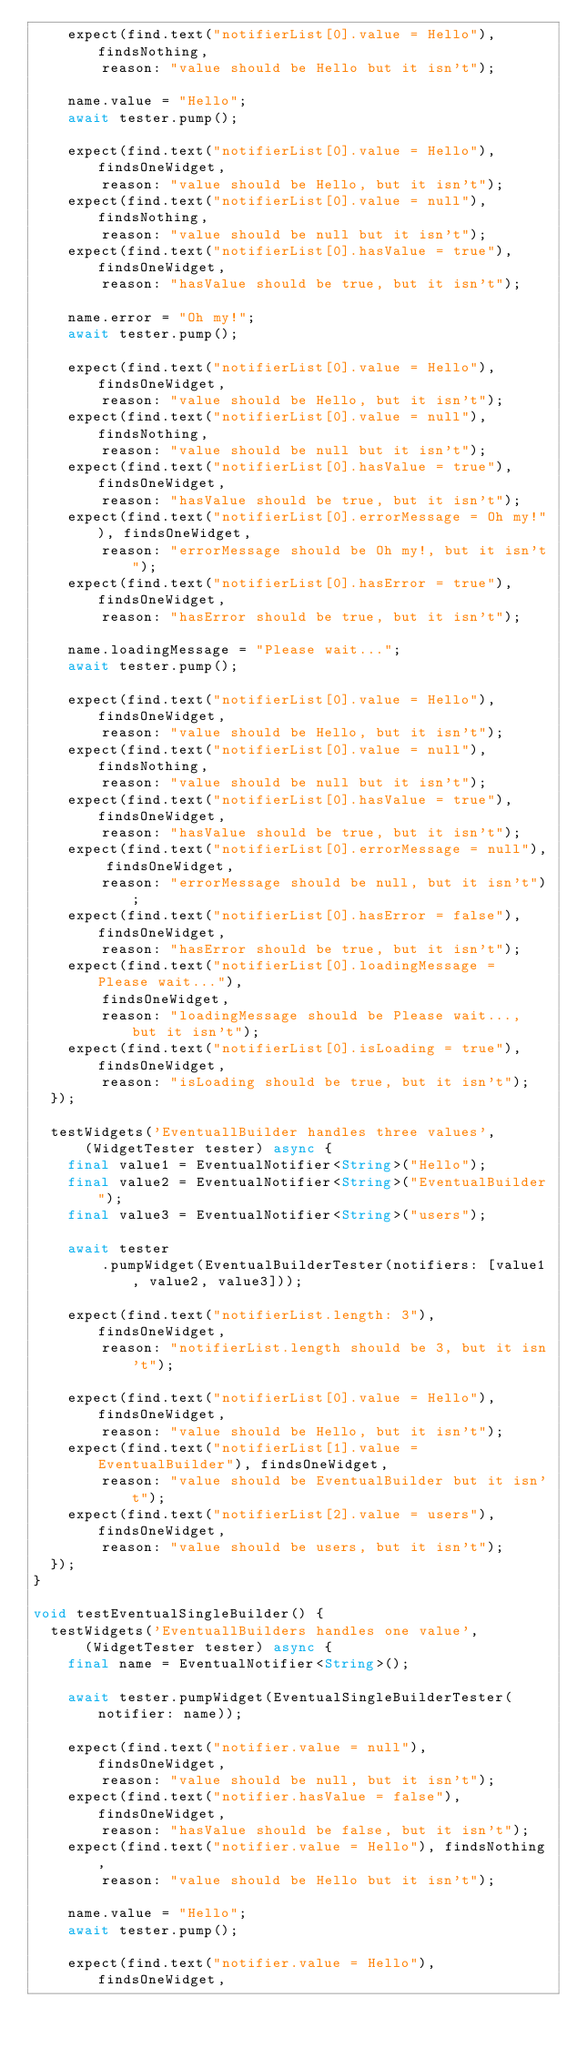Convert code to text. <code><loc_0><loc_0><loc_500><loc_500><_Dart_>    expect(find.text("notifierList[0].value = Hello"), findsNothing,
        reason: "value should be Hello but it isn't");

    name.value = "Hello";
    await tester.pump();

    expect(find.text("notifierList[0].value = Hello"), findsOneWidget,
        reason: "value should be Hello, but it isn't");
    expect(find.text("notifierList[0].value = null"), findsNothing,
        reason: "value should be null but it isn't");
    expect(find.text("notifierList[0].hasValue = true"), findsOneWidget,
        reason: "hasValue should be true, but it isn't");

    name.error = "Oh my!";
    await tester.pump();

    expect(find.text("notifierList[0].value = Hello"), findsOneWidget,
        reason: "value should be Hello, but it isn't");
    expect(find.text("notifierList[0].value = null"), findsNothing,
        reason: "value should be null but it isn't");
    expect(find.text("notifierList[0].hasValue = true"), findsOneWidget,
        reason: "hasValue should be true, but it isn't");
    expect(find.text("notifierList[0].errorMessage = Oh my!"), findsOneWidget,
        reason: "errorMessage should be Oh my!, but it isn't");
    expect(find.text("notifierList[0].hasError = true"), findsOneWidget,
        reason: "hasError should be true, but it isn't");

    name.loadingMessage = "Please wait...";
    await tester.pump();

    expect(find.text("notifierList[0].value = Hello"), findsOneWidget,
        reason: "value should be Hello, but it isn't");
    expect(find.text("notifierList[0].value = null"), findsNothing,
        reason: "value should be null but it isn't");
    expect(find.text("notifierList[0].hasValue = true"), findsOneWidget,
        reason: "hasValue should be true, but it isn't");
    expect(find.text("notifierList[0].errorMessage = null"), findsOneWidget,
        reason: "errorMessage should be null, but it isn't");
    expect(find.text("notifierList[0].hasError = false"), findsOneWidget,
        reason: "hasError should be true, but it isn't");
    expect(find.text("notifierList[0].loadingMessage = Please wait..."),
        findsOneWidget,
        reason: "loadingMessage should be Please wait..., but it isn't");
    expect(find.text("notifierList[0].isLoading = true"), findsOneWidget,
        reason: "isLoading should be true, but it isn't");
  });

  testWidgets('EventuallBuilder handles three values',
      (WidgetTester tester) async {
    final value1 = EventualNotifier<String>("Hello");
    final value2 = EventualNotifier<String>("EventualBuilder");
    final value3 = EventualNotifier<String>("users");

    await tester
        .pumpWidget(EventualBuilderTester(notifiers: [value1, value2, value3]));

    expect(find.text("notifierList.length: 3"), findsOneWidget,
        reason: "notifierList.length should be 3, but it isn't");

    expect(find.text("notifierList[0].value = Hello"), findsOneWidget,
        reason: "value should be Hello, but it isn't");
    expect(find.text("notifierList[1].value = EventualBuilder"), findsOneWidget,
        reason: "value should be EventualBuilder but it isn't");
    expect(find.text("notifierList[2].value = users"), findsOneWidget,
        reason: "value should be users, but it isn't");
  });
}

void testEventualSingleBuilder() {
  testWidgets('EventuallBuilders handles one value',
      (WidgetTester tester) async {
    final name = EventualNotifier<String>();

    await tester.pumpWidget(EventualSingleBuilderTester(notifier: name));

    expect(find.text("notifier.value = null"), findsOneWidget,
        reason: "value should be null, but it isn't");
    expect(find.text("notifier.hasValue = false"), findsOneWidget,
        reason: "hasValue should be false, but it isn't");
    expect(find.text("notifier.value = Hello"), findsNothing,
        reason: "value should be Hello but it isn't");

    name.value = "Hello";
    await tester.pump();

    expect(find.text("notifier.value = Hello"), findsOneWidget,</code> 